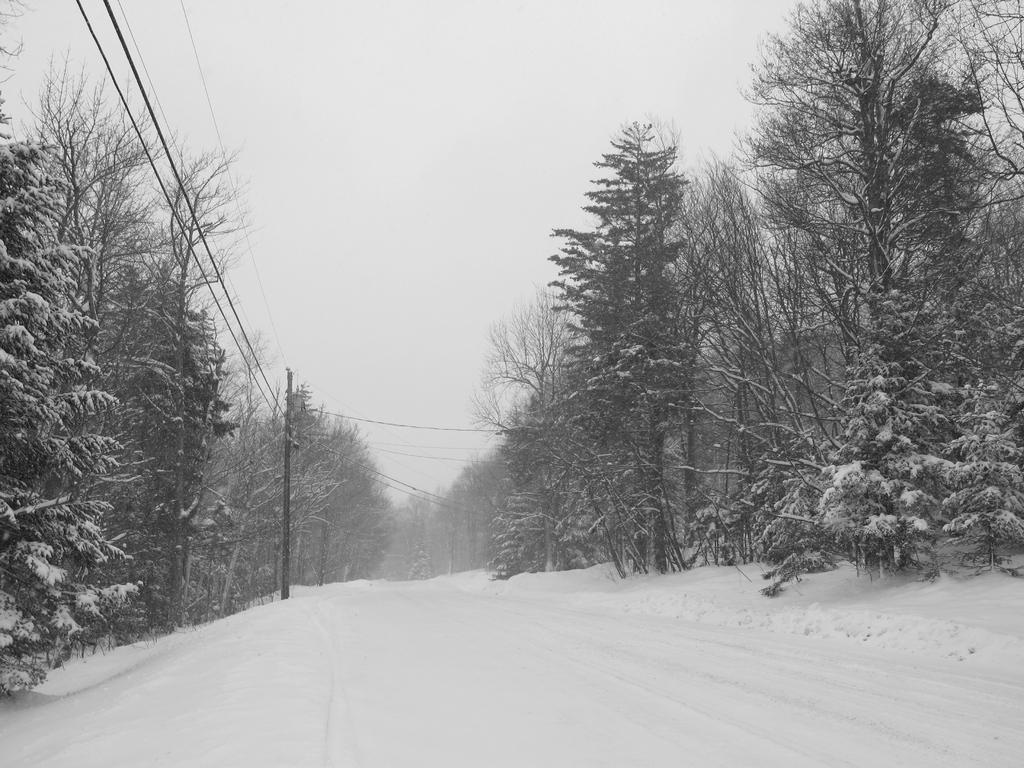Can you describe this image briefly? At the bottom of the picture, we see ice. On either side of the picture, we see trees, electric poles and wires. In the background, we see the trees which are covered with ice. At the top, we see the sky. 